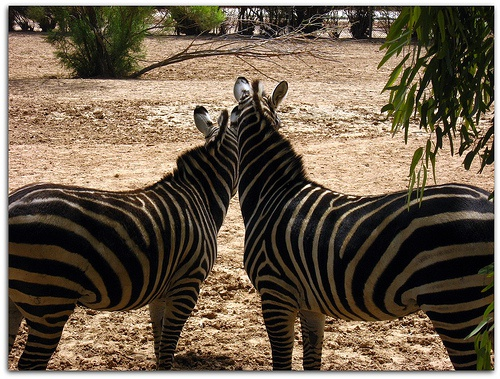Describe the objects in this image and their specific colors. I can see zebra in white, black, darkgreen, and gray tones and zebra in white, black, maroon, and gray tones in this image. 